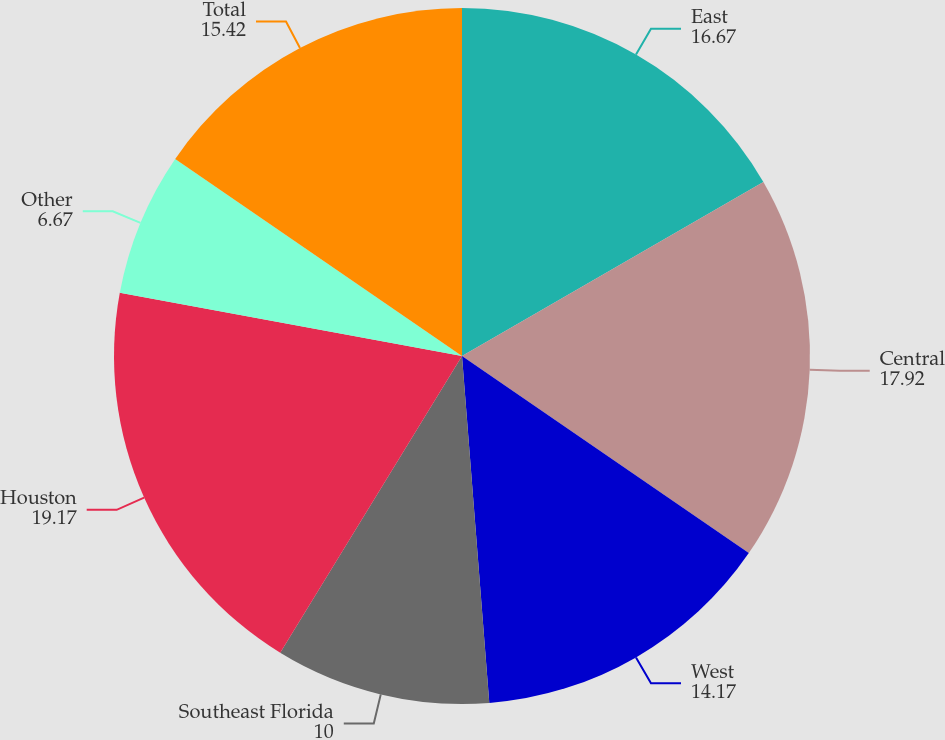Convert chart to OTSL. <chart><loc_0><loc_0><loc_500><loc_500><pie_chart><fcel>East<fcel>Central<fcel>West<fcel>Southeast Florida<fcel>Houston<fcel>Other<fcel>Total<nl><fcel>16.67%<fcel>17.92%<fcel>14.17%<fcel>10.0%<fcel>19.17%<fcel>6.67%<fcel>15.42%<nl></chart> 